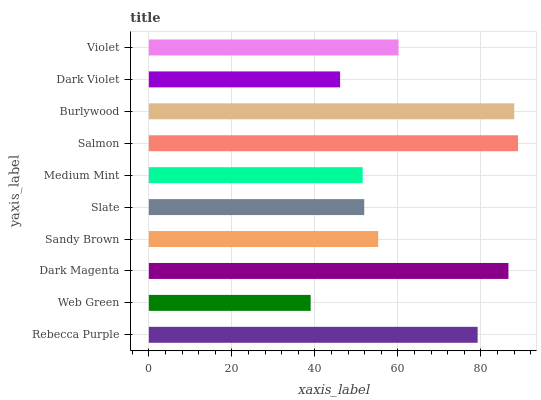Is Web Green the minimum?
Answer yes or no. Yes. Is Salmon the maximum?
Answer yes or no. Yes. Is Dark Magenta the minimum?
Answer yes or no. No. Is Dark Magenta the maximum?
Answer yes or no. No. Is Dark Magenta greater than Web Green?
Answer yes or no. Yes. Is Web Green less than Dark Magenta?
Answer yes or no. Yes. Is Web Green greater than Dark Magenta?
Answer yes or no. No. Is Dark Magenta less than Web Green?
Answer yes or no. No. Is Violet the high median?
Answer yes or no. Yes. Is Sandy Brown the low median?
Answer yes or no. Yes. Is Dark Violet the high median?
Answer yes or no. No. Is Dark Violet the low median?
Answer yes or no. No. 